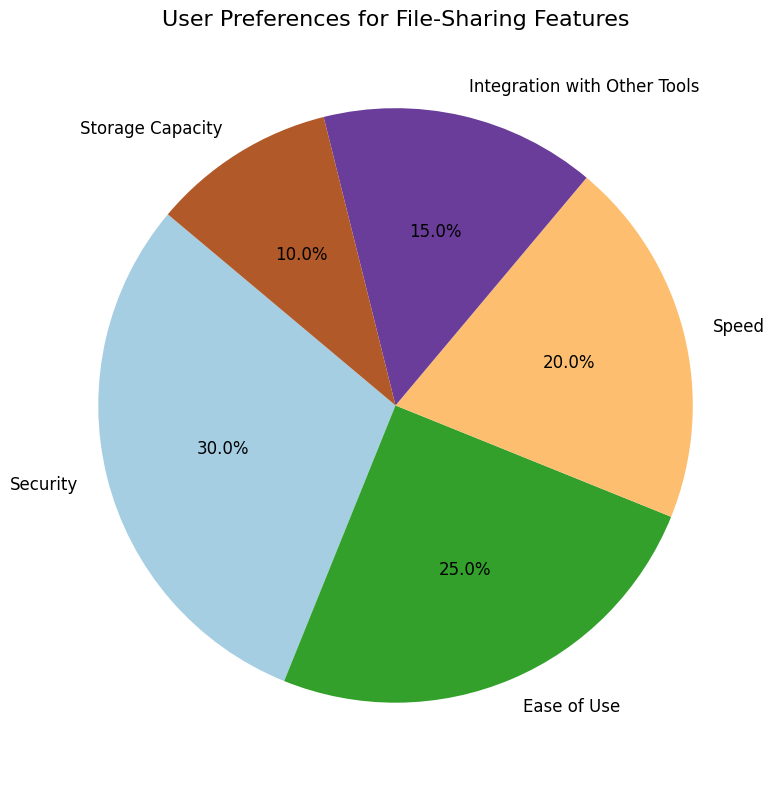What's the largest category in the chart? Look at the pie chart and identify which category occupies the largest segment. The largest segment corresponds to Security, which is 30%.
Answer: Security Which category has the smallest percentage? Look at the pie chart and identify which category occupies the smallest segment. The smallest segment corresponds to Storage Capacity, which is 10%.
Answer: Storage Capacity How much larger is the Security category compared to Speed? Compare the percentage of Security (30%) to that of Speed (20%). The difference is 30% - 20% = 10%.
Answer: 10% What is the sum of the percentages for Speed and Integration with Other Tools? Add the percentages of Speed (20%) and Integration with Other Tools (15%). The sum is 20% + 15% = 35%.
Answer: 35% Which category is more preferred: Ease of Use or Integration with Other Tools? Compare the percentage of Ease of Use (25%) to that of Integration with Other Tools (15%). Ease of Use is more preferred.
Answer: Ease of Use What is the percentage difference between Storage Capacity and Ease of Use? Subtract the percentage of Storage Capacity (10%) from Ease of Use (25%). The difference is 25% - 10% = 15%.
Answer: 15% Which two categories combined represent half of the total preferences (50%)? Identify two categories whose combined percentages equal 50%. Security (30%) and Ease of Use (25%) together make 30% + 25% = 55%, which is just above 50%. Therefore, Security (30%) plus Speed (20%) equals 50%.
Answer: Security and Speed Arrange the categories in descending order of preference. List the categories from the highest to the lowest percentage: Security (30%), Ease of Use (25%), Speed (20%), Integration with Other Tools (15%), Storage Capacity (10%).
Answer: Security, Ease of Use, Speed, Integration with Other Tools, Storage Capacity If you combine the two least preferred categories, what percentage do they represent? Add the percentages of Integration with Other Tools (15%) and Storage Capacity (10%). The sum is 15% + 10% = 25%.
Answer: 25% 